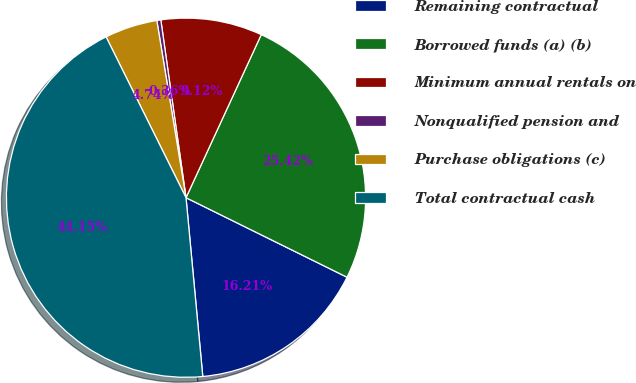<chart> <loc_0><loc_0><loc_500><loc_500><pie_chart><fcel>Remaining contractual<fcel>Borrowed funds (a) (b)<fcel>Minimum annual rentals on<fcel>Nonqualified pension and<fcel>Purchase obligations (c)<fcel>Total contractual cash<nl><fcel>16.21%<fcel>25.42%<fcel>9.12%<fcel>0.36%<fcel>4.74%<fcel>44.15%<nl></chart> 